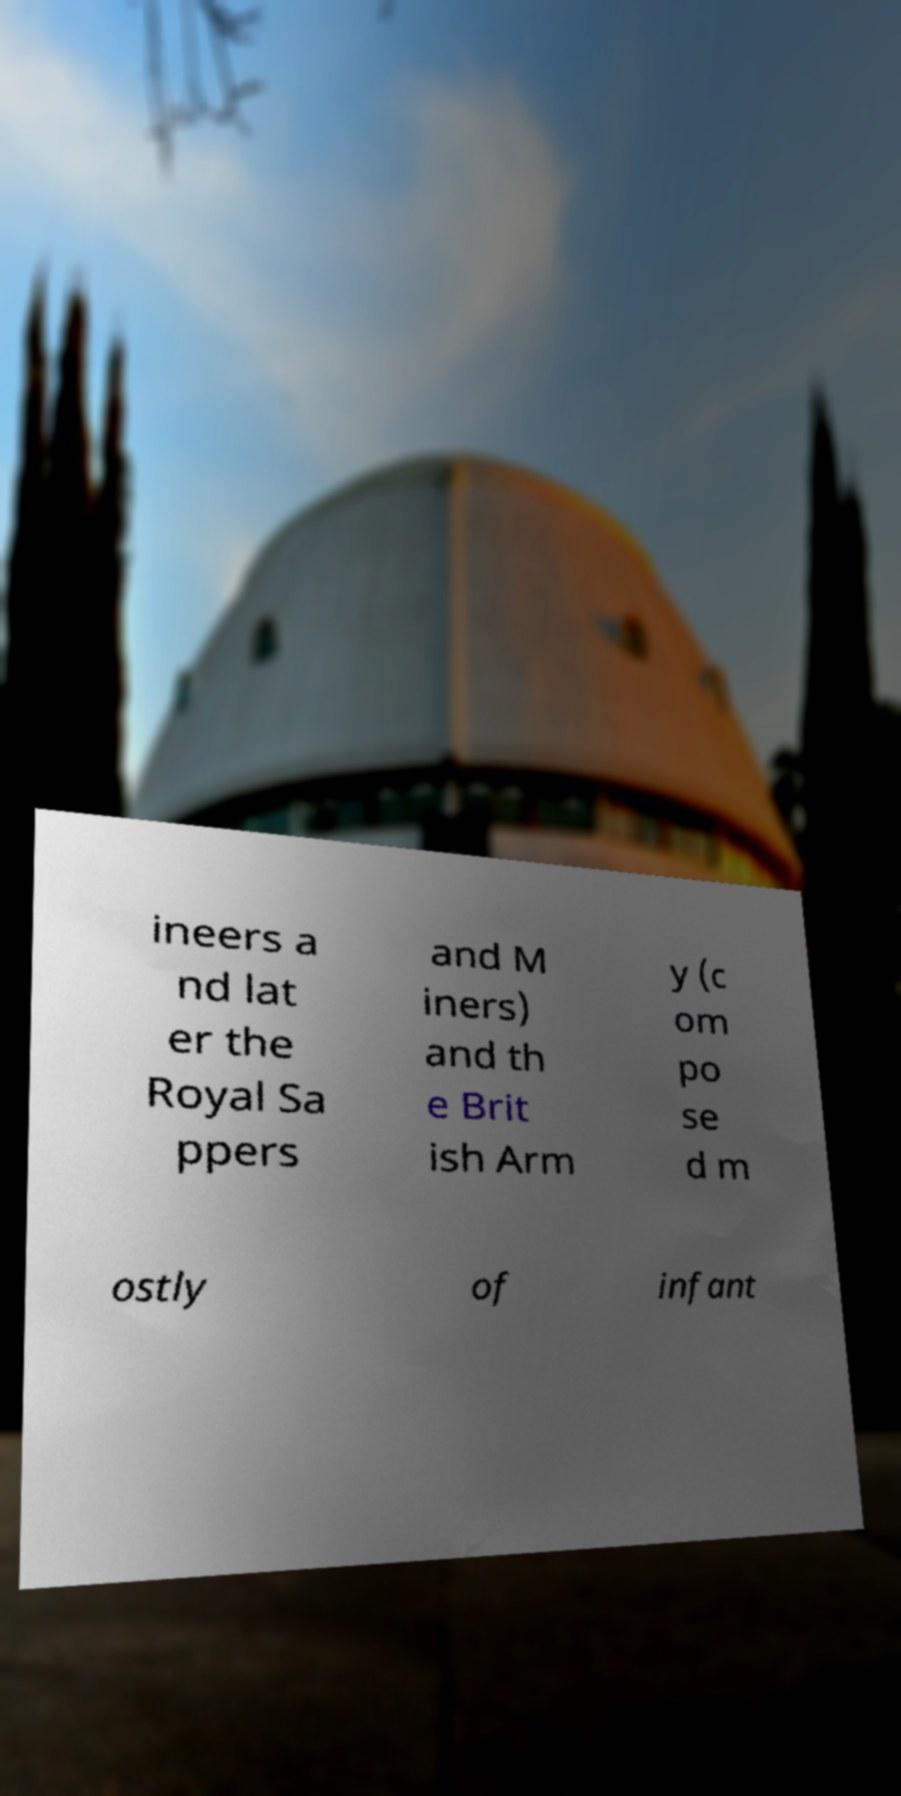There's text embedded in this image that I need extracted. Can you transcribe it verbatim? ineers a nd lat er the Royal Sa ppers and M iners) and th e Brit ish Arm y (c om po se d m ostly of infant 